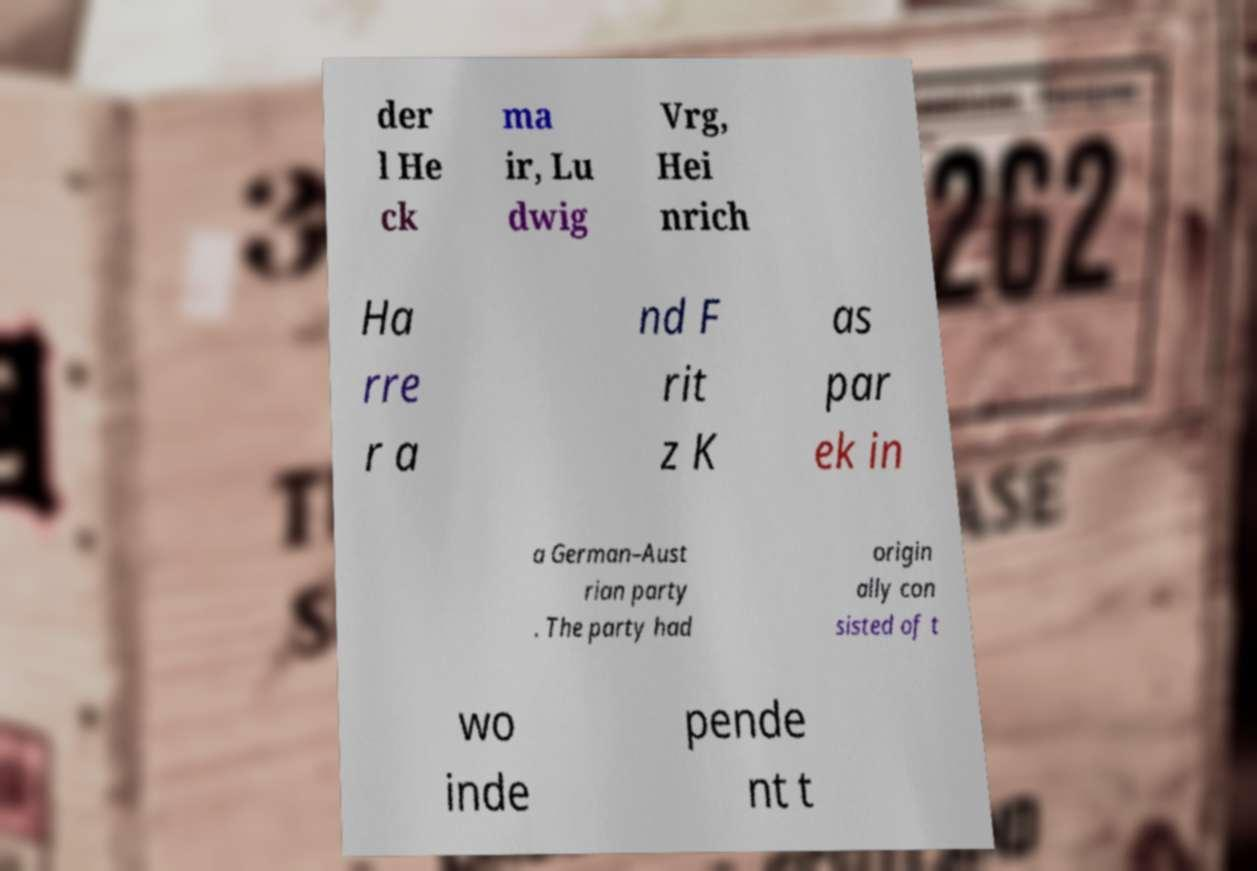Can you accurately transcribe the text from the provided image for me? der l He ck ma ir, Lu dwig Vrg, Hei nrich Ha rre r a nd F rit z K as par ek in a German–Aust rian party . The party had origin ally con sisted of t wo inde pende nt t 